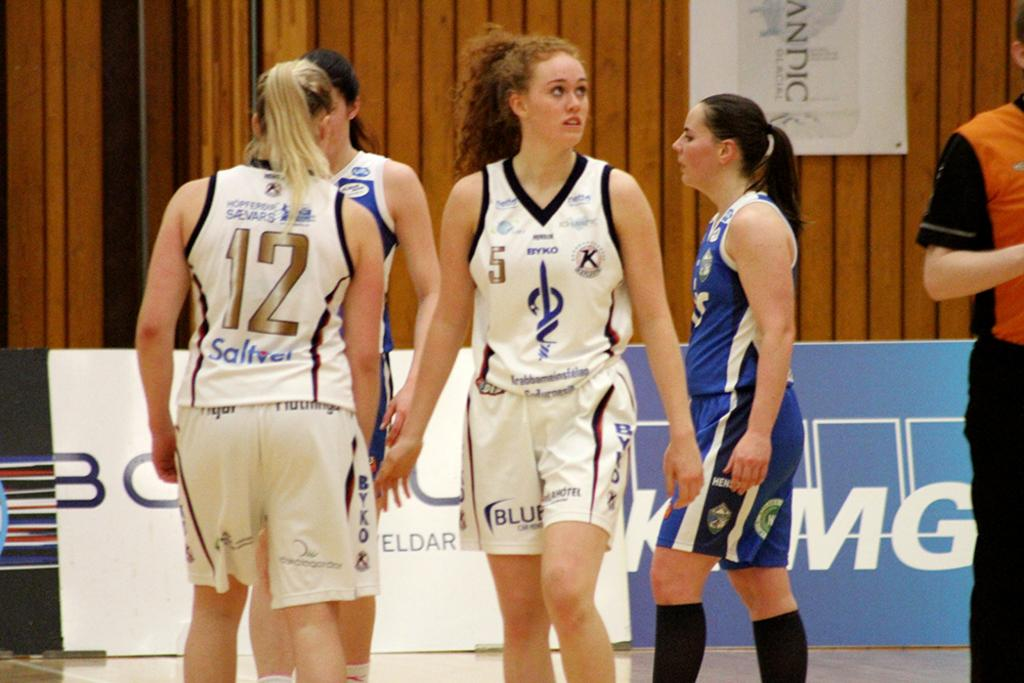<image>
Write a terse but informative summary of the picture. Girl wearing a white basketball jersey with the number 5 on it. 